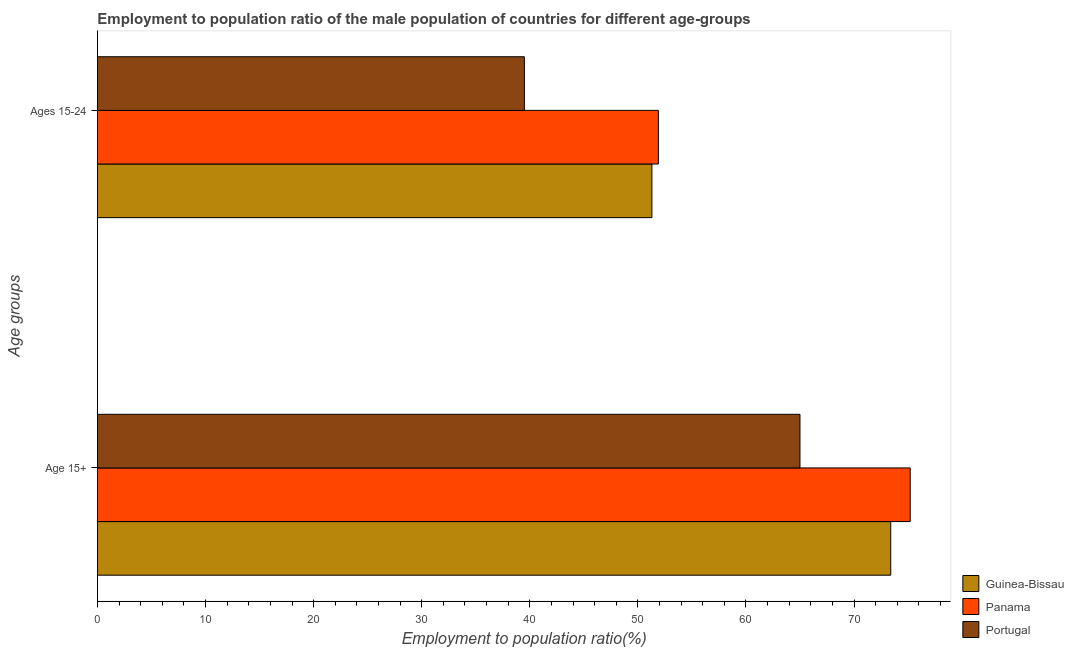How many different coloured bars are there?
Your answer should be compact. 3. Are the number of bars on each tick of the Y-axis equal?
Your answer should be compact. Yes. How many bars are there on the 1st tick from the top?
Offer a very short reply. 3. How many bars are there on the 2nd tick from the bottom?
Your answer should be very brief. 3. What is the label of the 2nd group of bars from the top?
Offer a very short reply. Age 15+. What is the employment to population ratio(age 15-24) in Guinea-Bissau?
Offer a terse response. 51.3. Across all countries, what is the maximum employment to population ratio(age 15-24)?
Make the answer very short. 51.9. Across all countries, what is the minimum employment to population ratio(age 15+)?
Give a very brief answer. 65. In which country was the employment to population ratio(age 15-24) maximum?
Your answer should be very brief. Panama. In which country was the employment to population ratio(age 15-24) minimum?
Provide a short and direct response. Portugal. What is the total employment to population ratio(age 15-24) in the graph?
Offer a very short reply. 142.7. What is the difference between the employment to population ratio(age 15+) in Portugal and that in Panama?
Your response must be concise. -10.2. What is the difference between the employment to population ratio(age 15+) in Panama and the employment to population ratio(age 15-24) in Guinea-Bissau?
Give a very brief answer. 23.9. What is the average employment to population ratio(age 15-24) per country?
Keep it short and to the point. 47.57. What is the difference between the employment to population ratio(age 15-24) and employment to population ratio(age 15+) in Portugal?
Make the answer very short. -25.5. In how many countries, is the employment to population ratio(age 15-24) greater than 68 %?
Your answer should be compact. 0. What is the ratio of the employment to population ratio(age 15-24) in Panama to that in Guinea-Bissau?
Provide a short and direct response. 1.01. What does the 2nd bar from the top in Age 15+ represents?
Ensure brevity in your answer.  Panama. What does the 3rd bar from the bottom in Age 15+ represents?
Your answer should be compact. Portugal. Are all the bars in the graph horizontal?
Offer a terse response. Yes. Are the values on the major ticks of X-axis written in scientific E-notation?
Provide a short and direct response. No. What is the title of the graph?
Your response must be concise. Employment to population ratio of the male population of countries for different age-groups. What is the label or title of the Y-axis?
Give a very brief answer. Age groups. What is the Employment to population ratio(%) of Guinea-Bissau in Age 15+?
Give a very brief answer. 73.4. What is the Employment to population ratio(%) of Panama in Age 15+?
Offer a very short reply. 75.2. What is the Employment to population ratio(%) in Guinea-Bissau in Ages 15-24?
Make the answer very short. 51.3. What is the Employment to population ratio(%) in Panama in Ages 15-24?
Ensure brevity in your answer.  51.9. What is the Employment to population ratio(%) of Portugal in Ages 15-24?
Offer a very short reply. 39.5. Across all Age groups, what is the maximum Employment to population ratio(%) in Guinea-Bissau?
Ensure brevity in your answer.  73.4. Across all Age groups, what is the maximum Employment to population ratio(%) in Panama?
Offer a terse response. 75.2. Across all Age groups, what is the maximum Employment to population ratio(%) of Portugal?
Ensure brevity in your answer.  65. Across all Age groups, what is the minimum Employment to population ratio(%) of Guinea-Bissau?
Provide a succinct answer. 51.3. Across all Age groups, what is the minimum Employment to population ratio(%) in Panama?
Provide a short and direct response. 51.9. Across all Age groups, what is the minimum Employment to population ratio(%) of Portugal?
Keep it short and to the point. 39.5. What is the total Employment to population ratio(%) in Guinea-Bissau in the graph?
Provide a short and direct response. 124.7. What is the total Employment to population ratio(%) in Panama in the graph?
Offer a terse response. 127.1. What is the total Employment to population ratio(%) of Portugal in the graph?
Keep it short and to the point. 104.5. What is the difference between the Employment to population ratio(%) in Guinea-Bissau in Age 15+ and that in Ages 15-24?
Provide a succinct answer. 22.1. What is the difference between the Employment to population ratio(%) of Panama in Age 15+ and that in Ages 15-24?
Your answer should be very brief. 23.3. What is the difference between the Employment to population ratio(%) in Portugal in Age 15+ and that in Ages 15-24?
Make the answer very short. 25.5. What is the difference between the Employment to population ratio(%) of Guinea-Bissau in Age 15+ and the Employment to population ratio(%) of Panama in Ages 15-24?
Offer a very short reply. 21.5. What is the difference between the Employment to population ratio(%) in Guinea-Bissau in Age 15+ and the Employment to population ratio(%) in Portugal in Ages 15-24?
Offer a terse response. 33.9. What is the difference between the Employment to population ratio(%) in Panama in Age 15+ and the Employment to population ratio(%) in Portugal in Ages 15-24?
Make the answer very short. 35.7. What is the average Employment to population ratio(%) of Guinea-Bissau per Age groups?
Your response must be concise. 62.35. What is the average Employment to population ratio(%) of Panama per Age groups?
Provide a short and direct response. 63.55. What is the average Employment to population ratio(%) in Portugal per Age groups?
Your response must be concise. 52.25. What is the difference between the Employment to population ratio(%) of Guinea-Bissau and Employment to population ratio(%) of Panama in Age 15+?
Make the answer very short. -1.8. What is the difference between the Employment to population ratio(%) of Guinea-Bissau and Employment to population ratio(%) of Portugal in Age 15+?
Give a very brief answer. 8.4. What is the difference between the Employment to population ratio(%) in Panama and Employment to population ratio(%) in Portugal in Age 15+?
Your answer should be very brief. 10.2. What is the difference between the Employment to population ratio(%) in Guinea-Bissau and Employment to population ratio(%) in Panama in Ages 15-24?
Offer a terse response. -0.6. What is the ratio of the Employment to population ratio(%) in Guinea-Bissau in Age 15+ to that in Ages 15-24?
Your answer should be very brief. 1.43. What is the ratio of the Employment to population ratio(%) of Panama in Age 15+ to that in Ages 15-24?
Offer a very short reply. 1.45. What is the ratio of the Employment to population ratio(%) of Portugal in Age 15+ to that in Ages 15-24?
Give a very brief answer. 1.65. What is the difference between the highest and the second highest Employment to population ratio(%) in Guinea-Bissau?
Keep it short and to the point. 22.1. What is the difference between the highest and the second highest Employment to population ratio(%) in Panama?
Provide a short and direct response. 23.3. What is the difference between the highest and the lowest Employment to population ratio(%) of Guinea-Bissau?
Provide a short and direct response. 22.1. What is the difference between the highest and the lowest Employment to population ratio(%) of Panama?
Your response must be concise. 23.3. What is the difference between the highest and the lowest Employment to population ratio(%) in Portugal?
Your answer should be very brief. 25.5. 